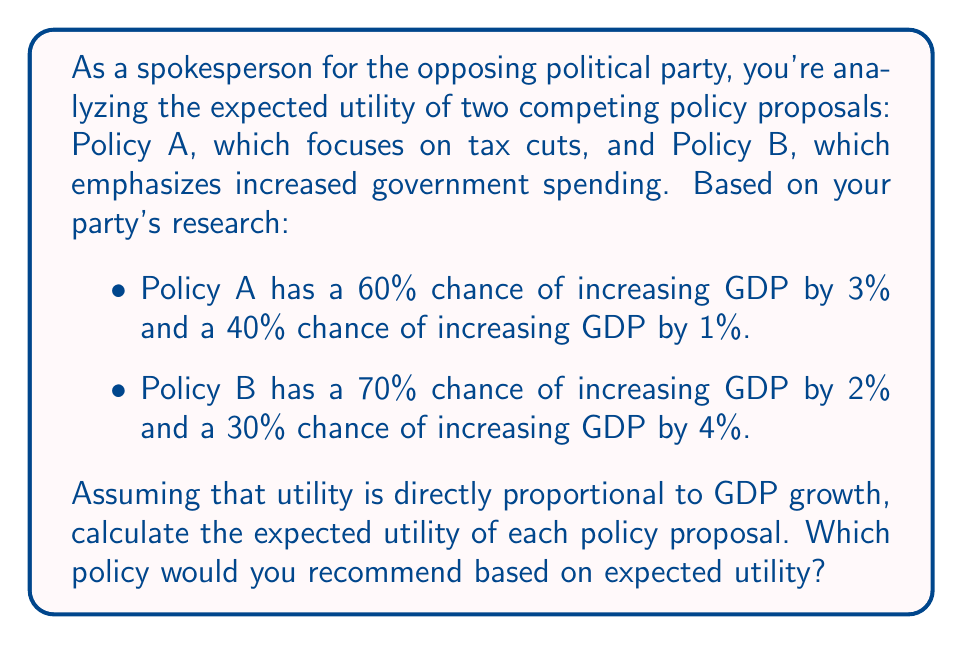What is the answer to this math problem? To solve this problem, we need to calculate the expected utility for each policy using probability theory. The expected utility is the sum of each possible outcome multiplied by its probability.

For Policy A:
1. Calculate the expected utility:
   $$E(U_A) = (0.60 \times 3\%) + (0.40 \times 1\%)$$
   $$E(U_A) = 1.8\% + 0.4\% = 2.2\%$$

For Policy B:
2. Calculate the expected utility:
   $$E(U_B) = (0.70 \times 2\%) + (0.30 \times 4\%)$$
   $$E(U_B) = 1.4\% + 1.2\% = 2.6\%$$

3. Compare the expected utilities:
   Policy A: 2.2%
   Policy B: 2.6%

Since Policy B has a higher expected utility (2.6% > 2.2%), it would be the recommended choice based on expected utility theory.
Answer: The expected utility of Policy A is 2.2%, and the expected utility of Policy B is 2.6%. Based on expected utility, Policy B should be recommended as it has a higher expected utility. 